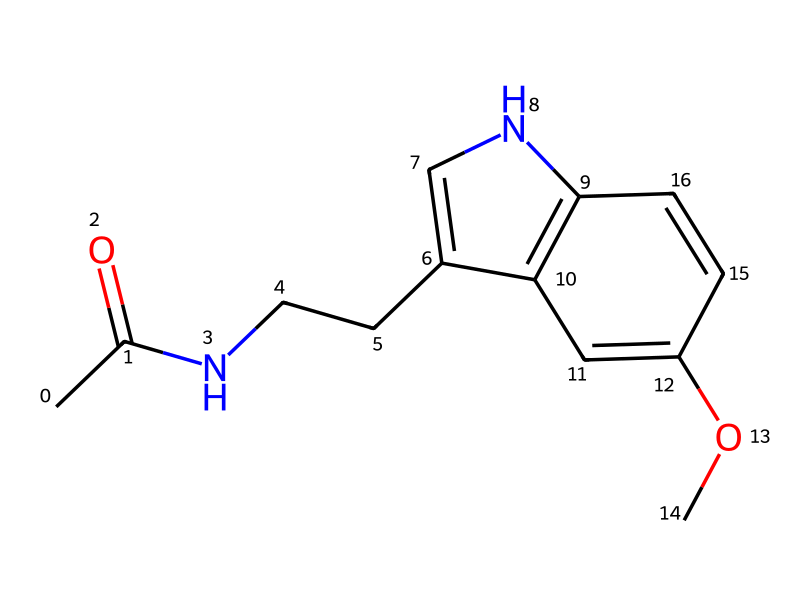What is the molecular formula of melatonin? The molecular composition can be identified by counting the atoms in the SMILES representation. Analyzing the structure reveals there are 13 carbon atoms, 16 hydrogen atoms, 2 nitrogen atoms, and 2 oxygen atoms, which gives the molecular formula C13H16N2O2.
Answer: C13H16N2O2 How many nitrogen atoms are present in melatonin? By examining the SMILES structure, we can clearly see two nitrogen atoms represented in the compound. Their presence is indicated by the 'N' notation in the chemical representation.
Answer: 2 What type of functional group is characteristic of imides present in melatonin? Imides contain a carbonyl group (C=O) adjacent to a nitrogen atom, which is identifiable in this structure. The presence of the carbonyl adjacent to the nitrogen atoms confirms its character as an imide.
Answer: carbonyl What is the total number of rings in the structure of melatonin? Upon inspecting the chemical structure rendered from the SMILES notation, one can identify a fused ring system. There are two distinct rings observed in the representation of melatonin.
Answer: 2 Does melatonin contain any aromatic systems? The presence of alternating double bonds within the rings is characteristic of aromatic compounds. In this SMILES representation, there are indeed aromatic rings present, indicated through their stable configurations.
Answer: yes Which atom is primarily responsible for melatonin's interaction with sleep receptors? The nitrogen atoms in the structure play a crucial role in the binding interactions with biological receptors responsible for sleep regulation. This demonstrates their importance for the hormone's functionality.
Answer: nitrogen 